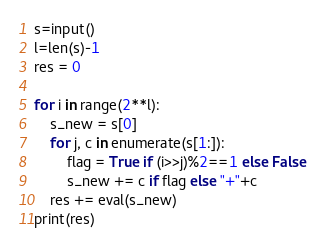<code> <loc_0><loc_0><loc_500><loc_500><_Python_>s=input()
l=len(s)-1
res = 0

for i in range(2**l):
    s_new = s[0]
    for j, c in enumerate(s[1:]):
        flag = True if (i>>j)%2==1 else False
        s_new += c if flag else "+"+c
    res += eval(s_new)
print(res)
</code> 